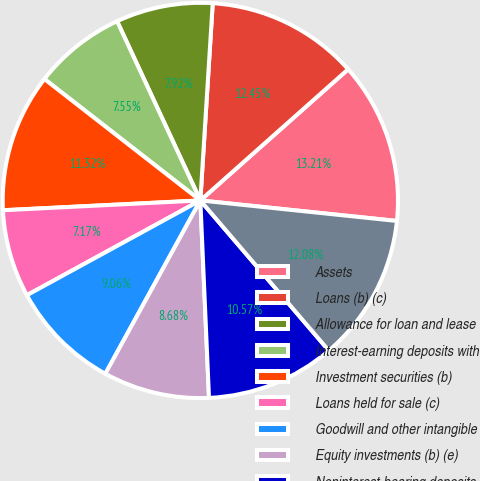Convert chart. <chart><loc_0><loc_0><loc_500><loc_500><pie_chart><fcel>Assets<fcel>Loans (b) (c)<fcel>Allowance for loan and lease<fcel>Interest-earning deposits with<fcel>Investment securities (b)<fcel>Loans held for sale (c)<fcel>Goodwill and other intangible<fcel>Equity investments (b) (e)<fcel>Noninterest-bearing deposits<fcel>Interest-bearing deposits<nl><fcel>13.21%<fcel>12.45%<fcel>7.92%<fcel>7.55%<fcel>11.32%<fcel>7.17%<fcel>9.06%<fcel>8.68%<fcel>10.57%<fcel>12.08%<nl></chart> 